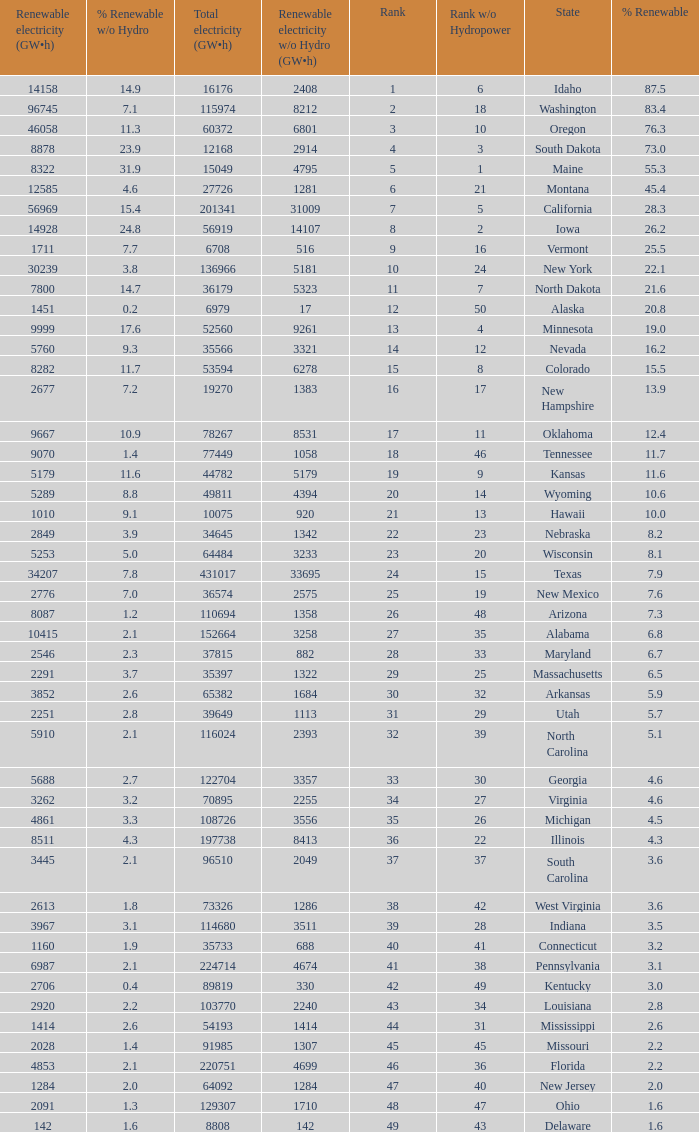What is the amount of renewable electricity without hydrogen power when the percentage of renewable energy is 83.4? 8212.0. 